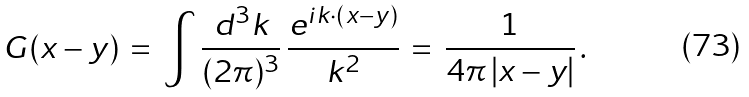Convert formula to latex. <formula><loc_0><loc_0><loc_500><loc_500>G ( x - y ) \, = \, \int \frac { d ^ { 3 } k } { ( 2 \pi ) ^ { 3 } } \, \frac { e ^ { i k \cdot ( x - y ) } } { k ^ { 2 } } \, = \, \frac { 1 } { 4 \pi \, | x - y | } \, .</formula> 